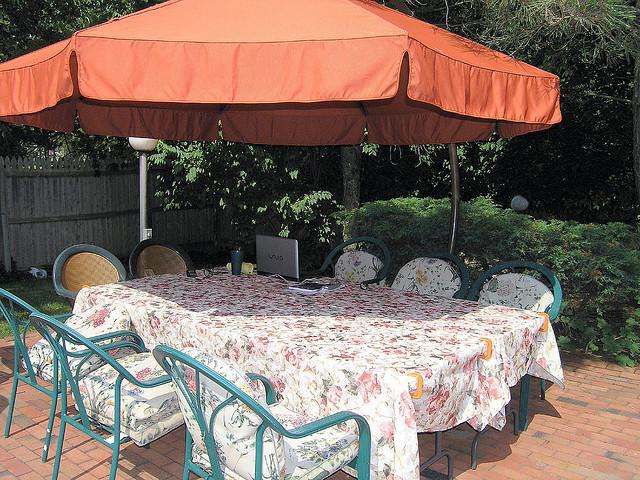Is someone getting ready to eat out?
Short answer required. No. How many chairs?
Keep it brief. 8. Is the tablecloth striped?
Be succinct. No. 